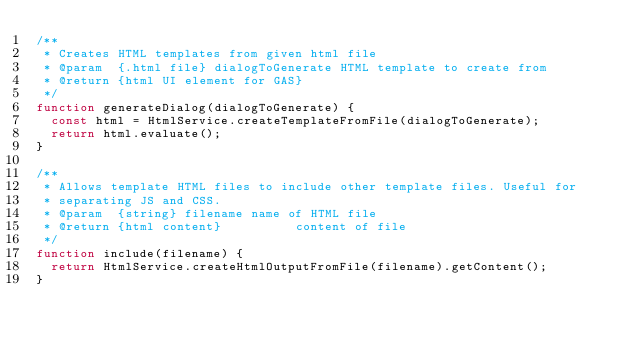Convert code to text. <code><loc_0><loc_0><loc_500><loc_500><_JavaScript_>/**
 * Creates HTML templates from given html file
 * @param  {.html file} dialogToGenerate HTML template to create from
 * @return {html UI element for GAS}
 */
function generateDialog(dialogToGenerate) {
	const html = HtmlService.createTemplateFromFile(dialogToGenerate);
	return html.evaluate();
}

/**
 * Allows template HTML files to include other template files. Useful for
 * separating JS and CSS.
 * @param  {string} filename name of HTML file
 * @return {html content}          content of file
 */
function include(filename) {
	return HtmlService.createHtmlOutputFromFile(filename).getContent();
}
</code> 